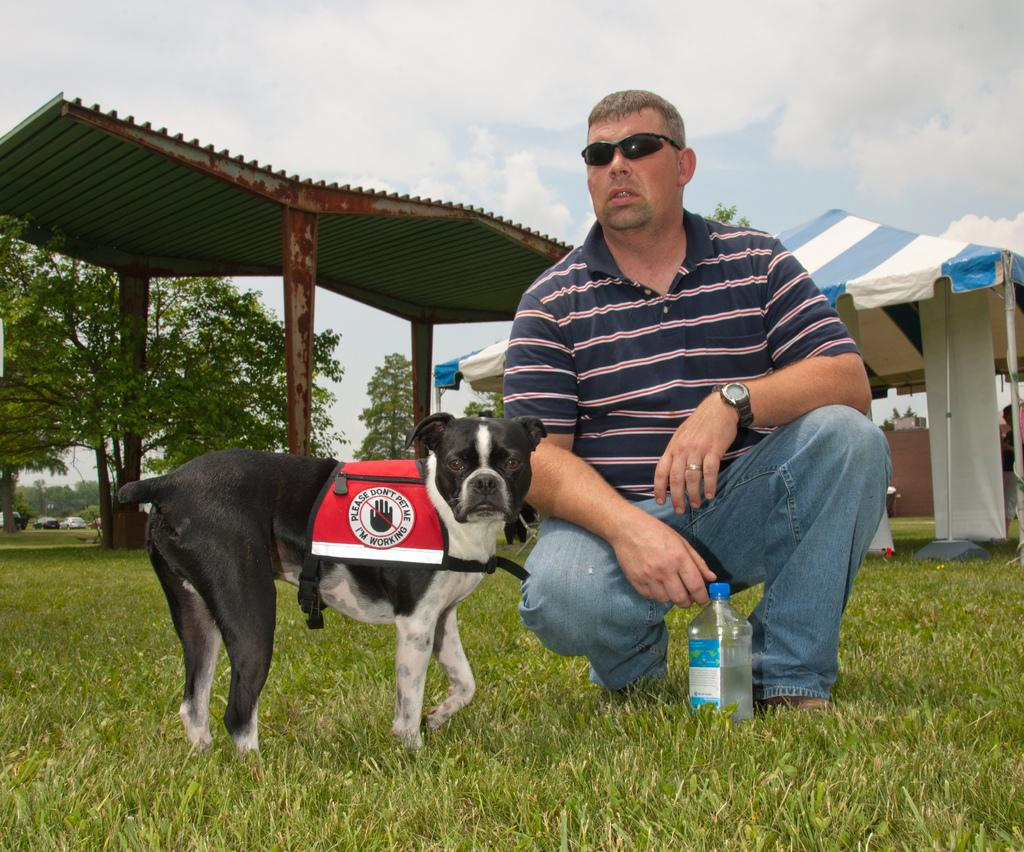Who is present in the image? There is a man in the image. What animal is present in the image? There is a dog in the image. How is the dog positioned in relation to the man? The dog is in front of the man. What objects can be seen in the background of the image? There is a bottle, a shed, a tree, and the sky visible in the background of the image. What type of cakes are being served on the airplane in the image? There is no airplane or cakes present in the image. How many potatoes can be seen growing near the tree in the image? There are no potatoes visible in the image; only a tree is present in the background. 